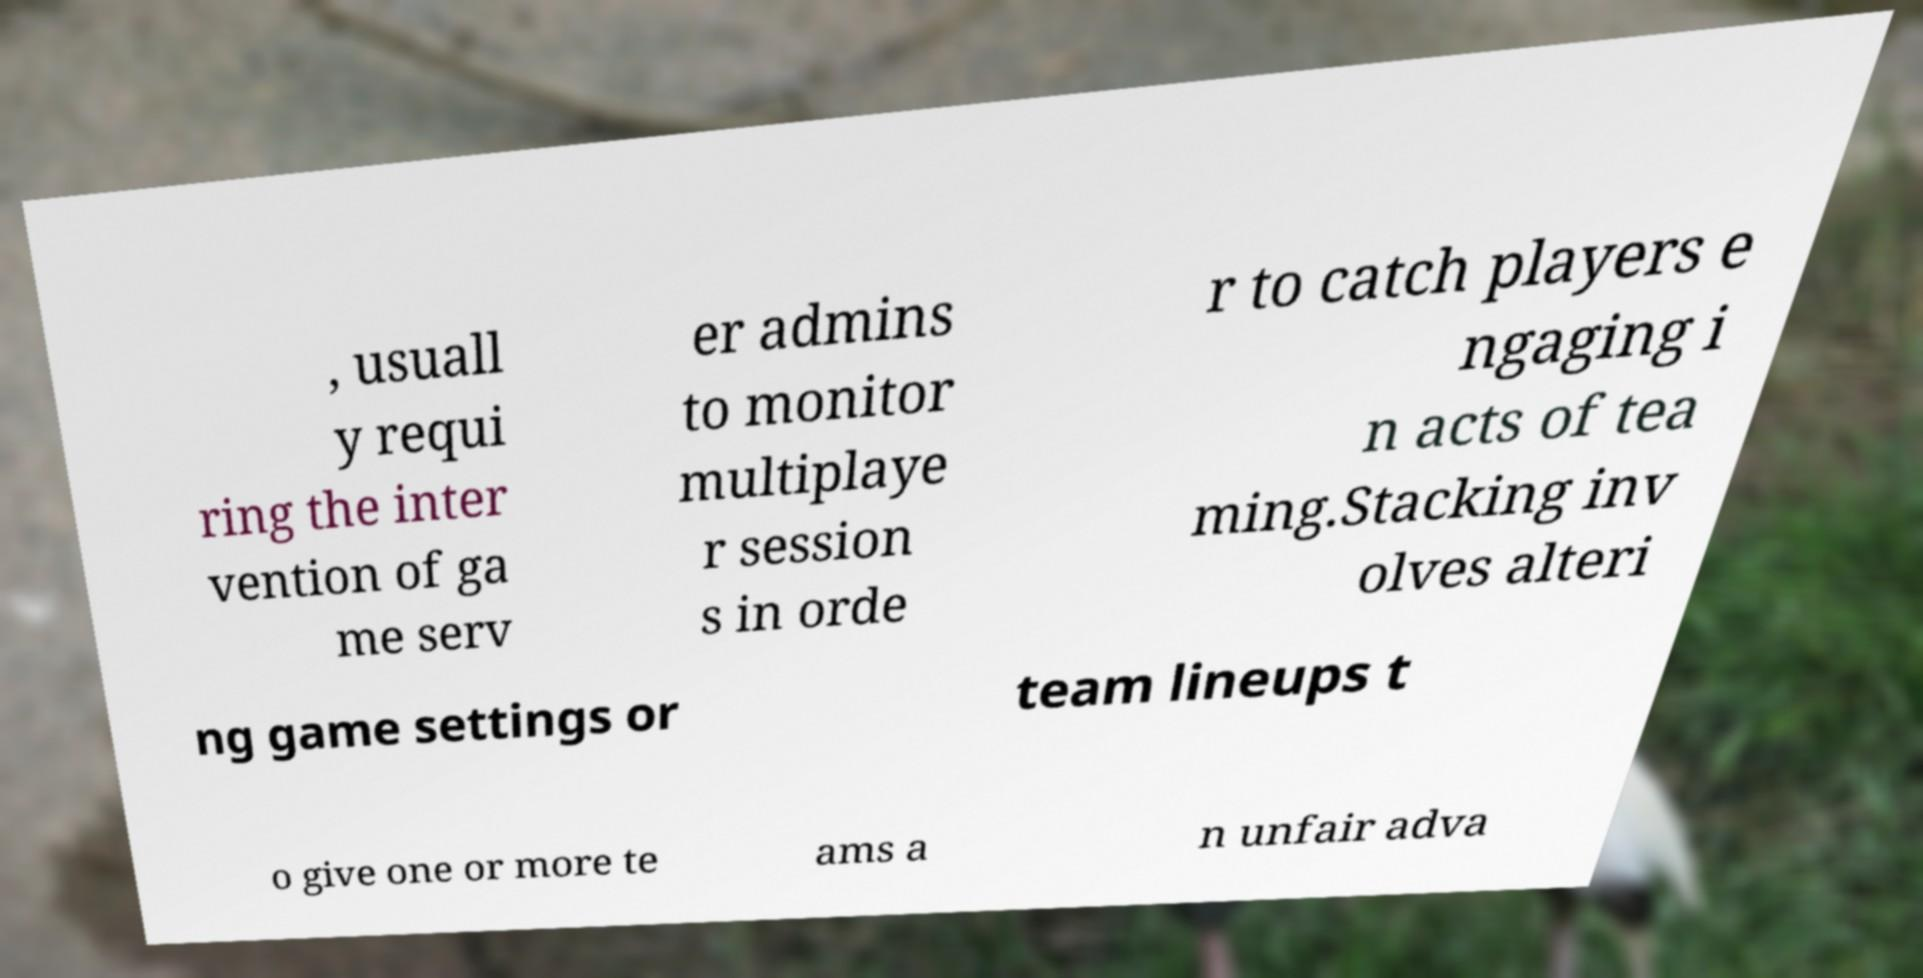Can you read and provide the text displayed in the image?This photo seems to have some interesting text. Can you extract and type it out for me? , usuall y requi ring the inter vention of ga me serv er admins to monitor multiplaye r session s in orde r to catch players e ngaging i n acts of tea ming.Stacking inv olves alteri ng game settings or team lineups t o give one or more te ams a n unfair adva 